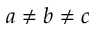<formula> <loc_0><loc_0><loc_500><loc_500>a \neq b \neq c</formula> 